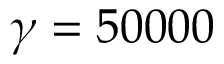Convert formula to latex. <formula><loc_0><loc_0><loc_500><loc_500>\gamma = 5 0 0 0 0</formula> 